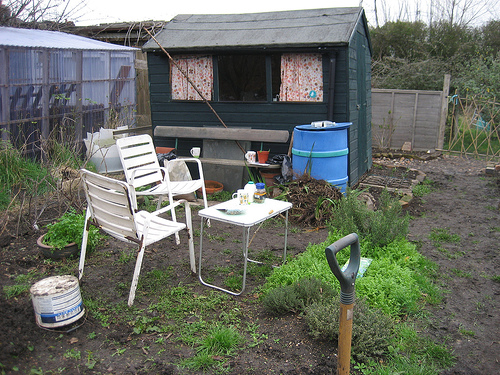<image>
Can you confirm if the plant is behind the chair? Yes. From this viewpoint, the plant is positioned behind the chair, with the chair partially or fully occluding the plant. 